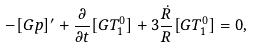Convert formula to latex. <formula><loc_0><loc_0><loc_500><loc_500>- [ G p ] ^ { \prime } + \frac { \partial } { \partial t } [ G T ^ { 0 } _ { 1 } ] + 3 \frac { \dot { R } } { R } [ G T ^ { 0 } _ { 1 } ] = 0 ,</formula> 